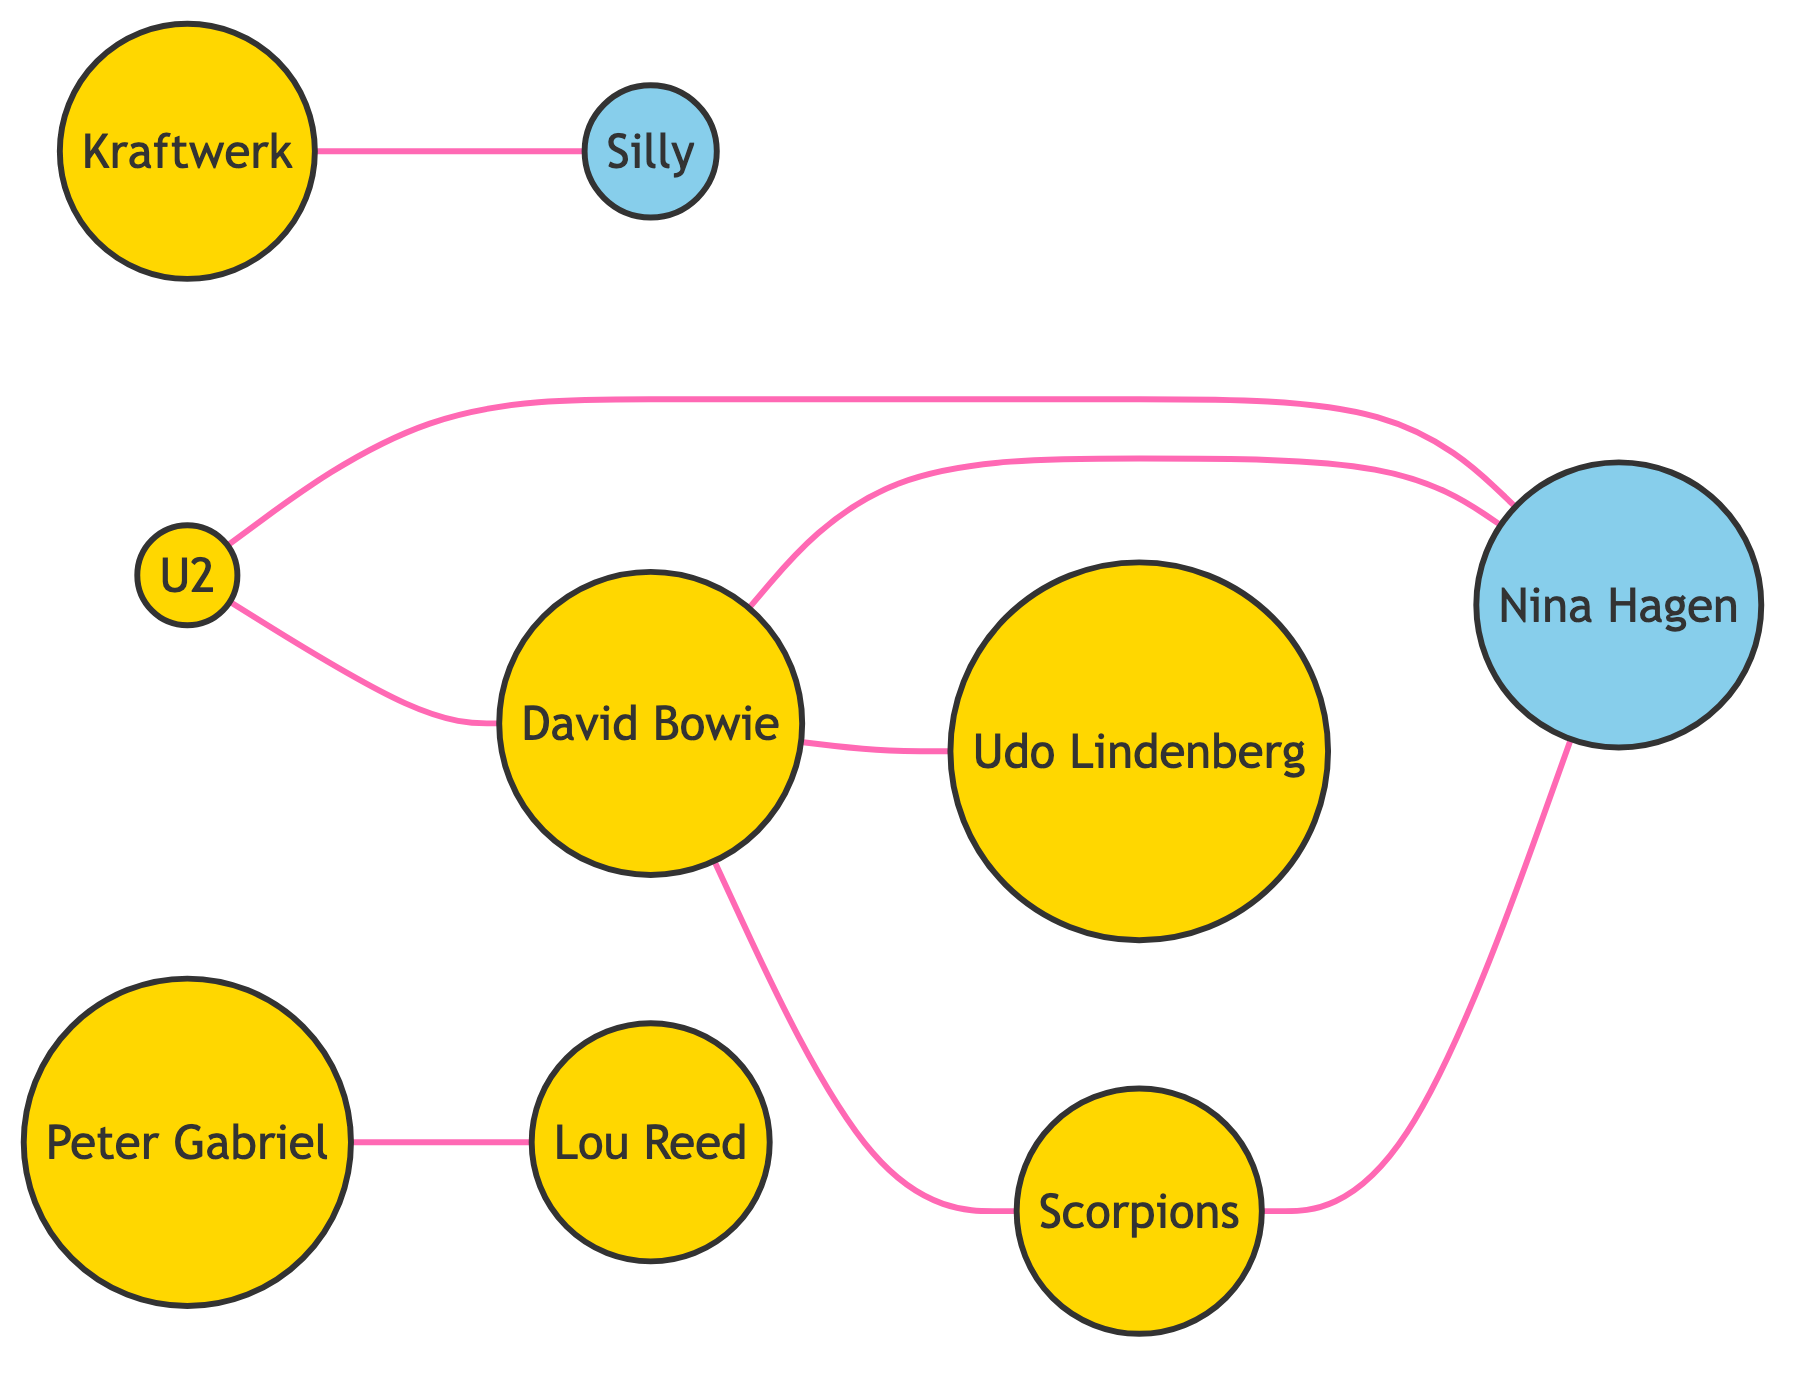How many nodes are in the diagram? The diagram includes nine distinct nodes representing different musicians and bands, each represented by their name.
Answer: 9 What type of relationship exists between David Bowie and Nina Hagen? The relationship is described as "Collaborated and influenced each other's work post-Berlin Wall," indicating a collaborative dynamic.
Answer: Collaborated and influenced each other's work post-Berlin Wall Who is connected to U2 in the diagram? U2 is connected to Nina Hagen, David Bowie, suggesting collaborative relationships with both artists.
Answer: Nina Hagen, David Bowie Which two artists supported Eastern European artists post-Berlin Wall? Peter Gabriel and Lou Reed are both indicated as having supported Eastern European artists, representing mutual interests in collaboration.
Answer: Peter Gabriel, Lou Reed What is the total number of edges in the diagram? By counting the connections between the nodes, there are eight edges representing different relationships.
Answer: 8 Which artist performed at the Berlin Wall? David Bowie is specifically noted for performing at the Berlin Wall, highlighting his impactful presence during this historical event.
Answer: David Bowie What do Scorpions and Nina Hagen symbolize together? Their joint performances symbolize unity post-Berlin Wall, illustrating the cultural impact of their collaboration.
Answer: Unity post-Berlin Wall Which band is famous for the song 'Wind of Change'? The Scorpions are recognized for their song 'Wind of Change,' which is a symbolic representation of the fall of the Berlin Wall.
Answer: Scorpions What genre does Udo Lindenberg's music belong to? Udo Lindenberg is classified as a rock musician, reflecting the genre prevalent in his collaborations.
Answer: Rock musician 